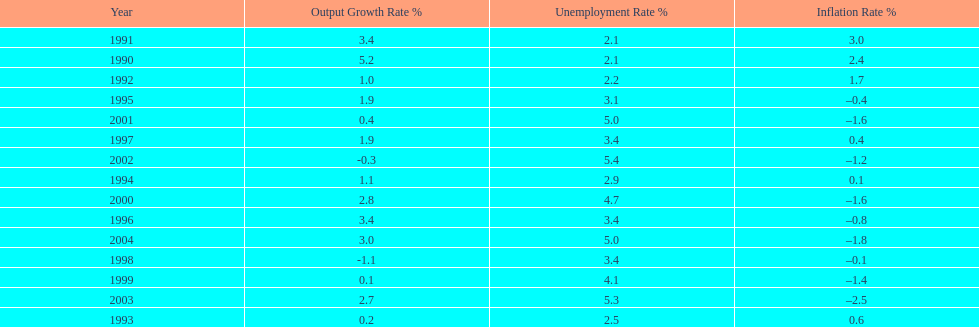Were the highest unemployment rates in japan before or after the year 2000? After. 